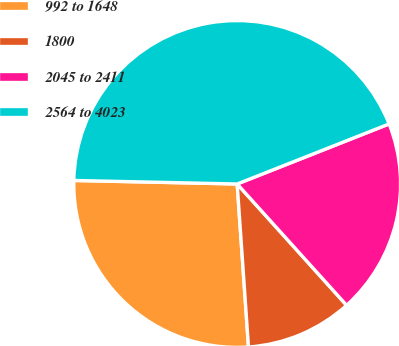Convert chart. <chart><loc_0><loc_0><loc_500><loc_500><pie_chart><fcel>992 to 1648<fcel>1800<fcel>2045 to 2411<fcel>2564 to 4023<nl><fcel>26.45%<fcel>10.58%<fcel>19.31%<fcel>43.67%<nl></chart> 